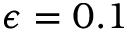<formula> <loc_0><loc_0><loc_500><loc_500>\epsilon = 0 . 1</formula> 